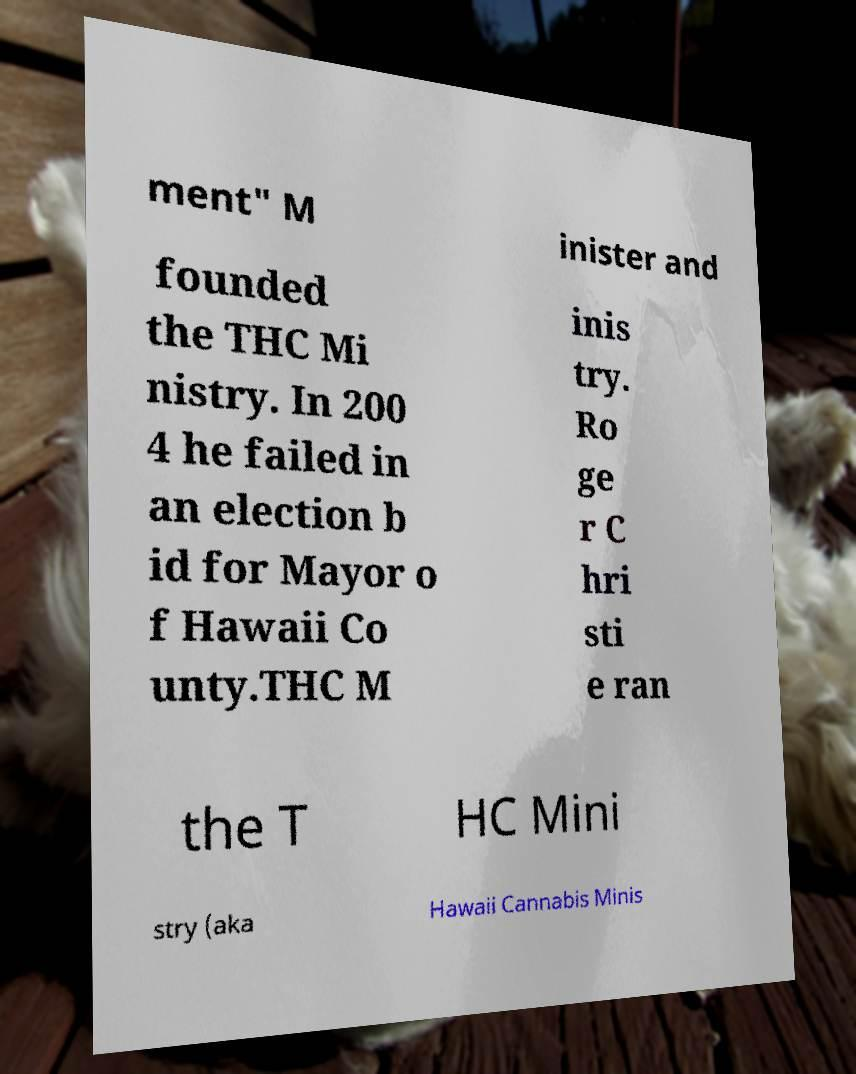Could you assist in decoding the text presented in this image and type it out clearly? ment" M inister and founded the THC Mi nistry. In 200 4 he failed in an election b id for Mayor o f Hawaii Co unty.THC M inis try. Ro ge r C hri sti e ran the T HC Mini stry (aka Hawaii Cannabis Minis 